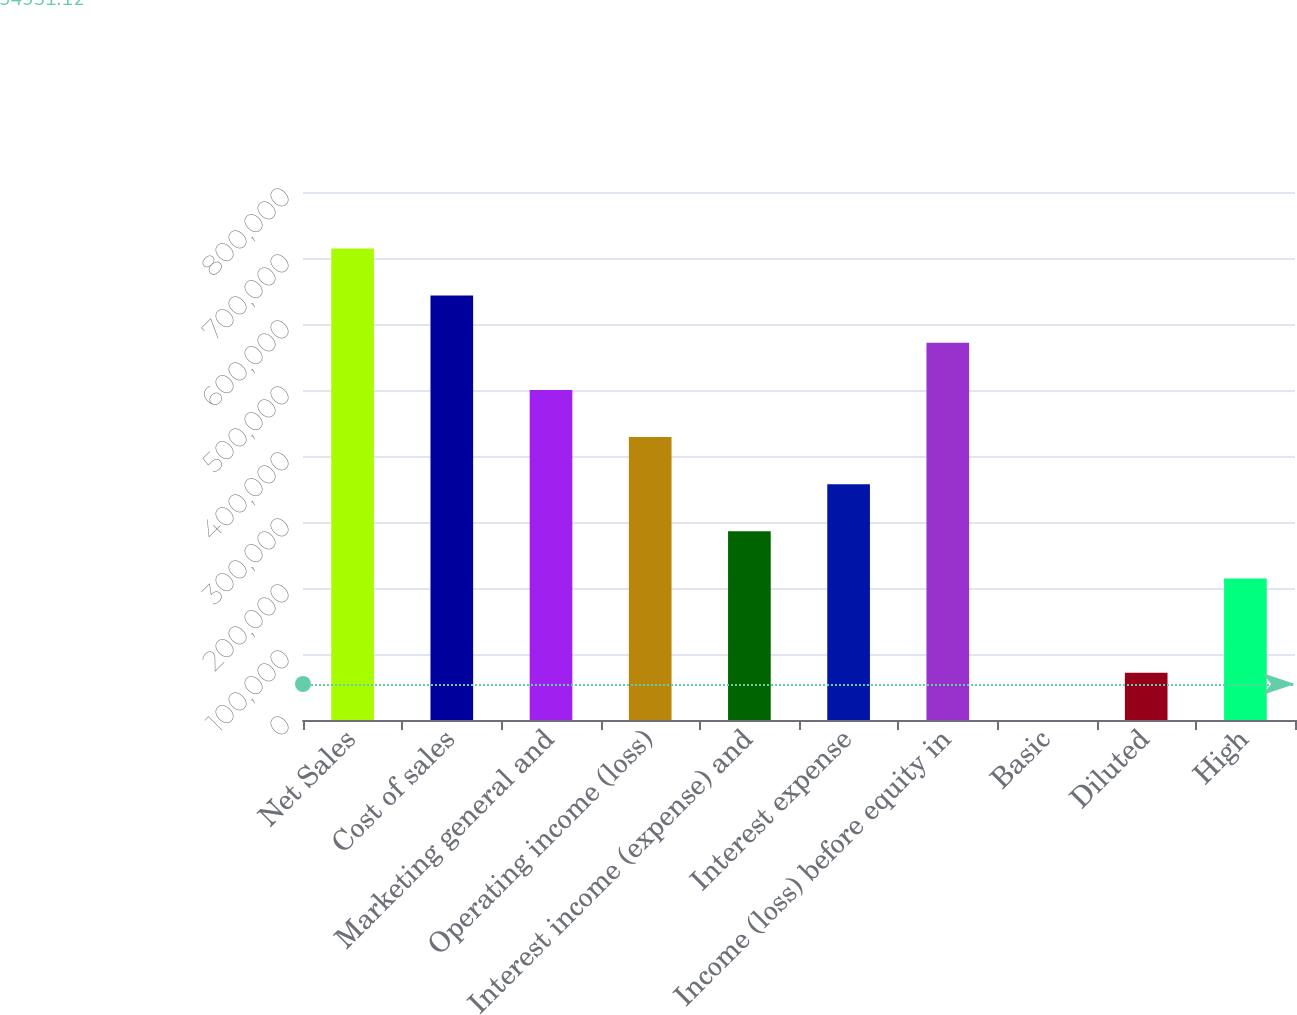Convert chart to OTSL. <chart><loc_0><loc_0><loc_500><loc_500><bar_chart><fcel>Net Sales<fcel>Cost of sales<fcel>Marketing general and<fcel>Operating income (loss)<fcel>Interest income (expense) and<fcel>Interest expense<fcel>Income (loss) before equity in<fcel>Basic<fcel>Diluted<fcel>High<nl><fcel>714555<fcel>643100<fcel>500189<fcel>428733<fcel>285822<fcel>357278<fcel>571644<fcel>0.42<fcel>71455.9<fcel>214367<nl></chart> 